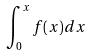Convert formula to latex. <formula><loc_0><loc_0><loc_500><loc_500>\int _ { 0 } ^ { x } f ( x ) d x</formula> 